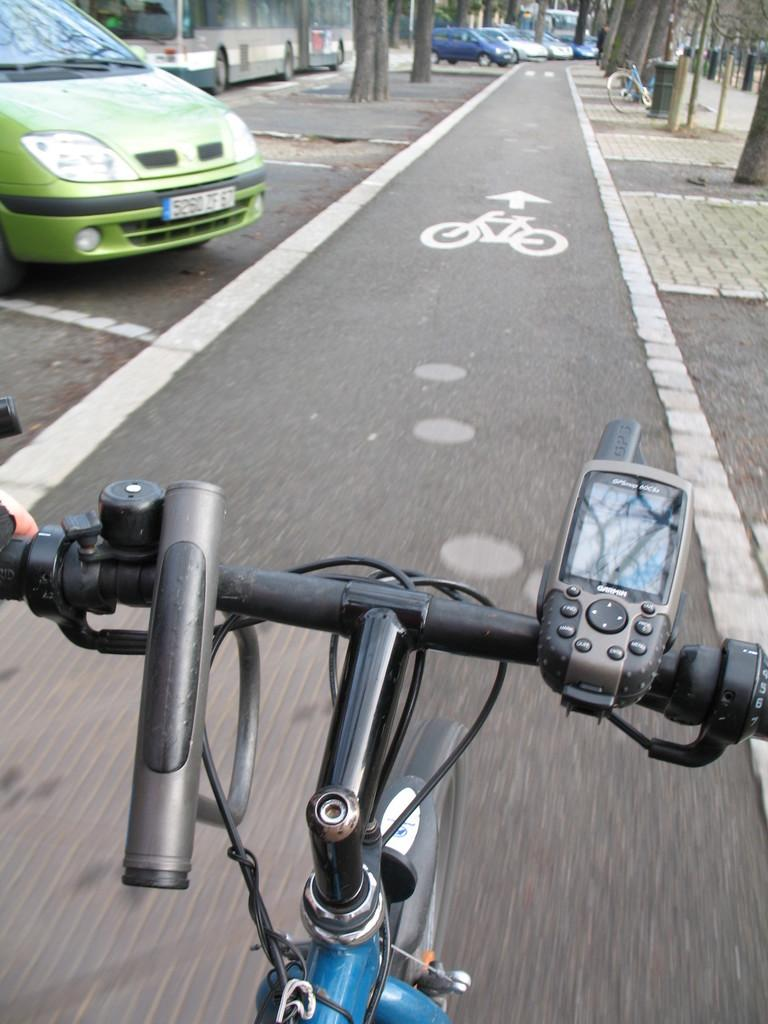What type of transportation is featured in the image? There are bicycles and vehicles in the image. What is the setting of the image? There is a road in the image. What type of vegetation can be seen in the image? There are trees in the image. What object is present for waste disposal? There is a dustbin in the image. What structures are present along the road? There are poles in the image. What letter is being dropped from the sky in the image? There is no letter being dropped from the sky in the image. What type of leaf can be seen falling from the trees in the image? There are no leaves falling from the trees in the image; it is not a seasonal image. 